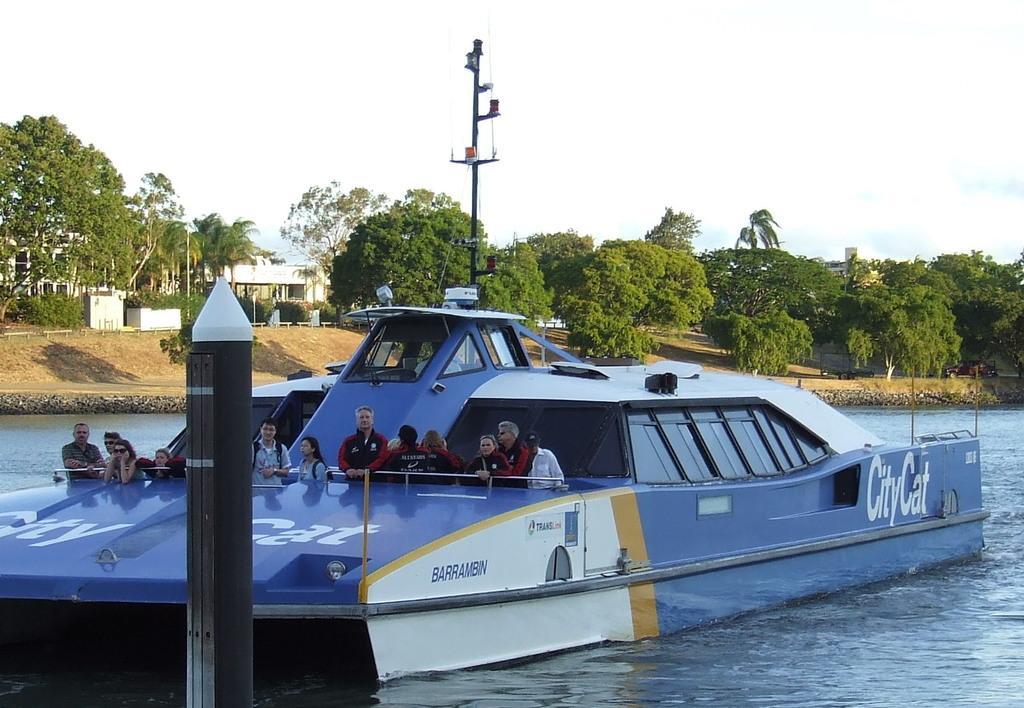Please provide a concise description of this image. In this image in front there is a ship in the water and we can see a few people are standing in the ship. In front of the ship there is a pole. In the background there are trees, buildings and sky. 